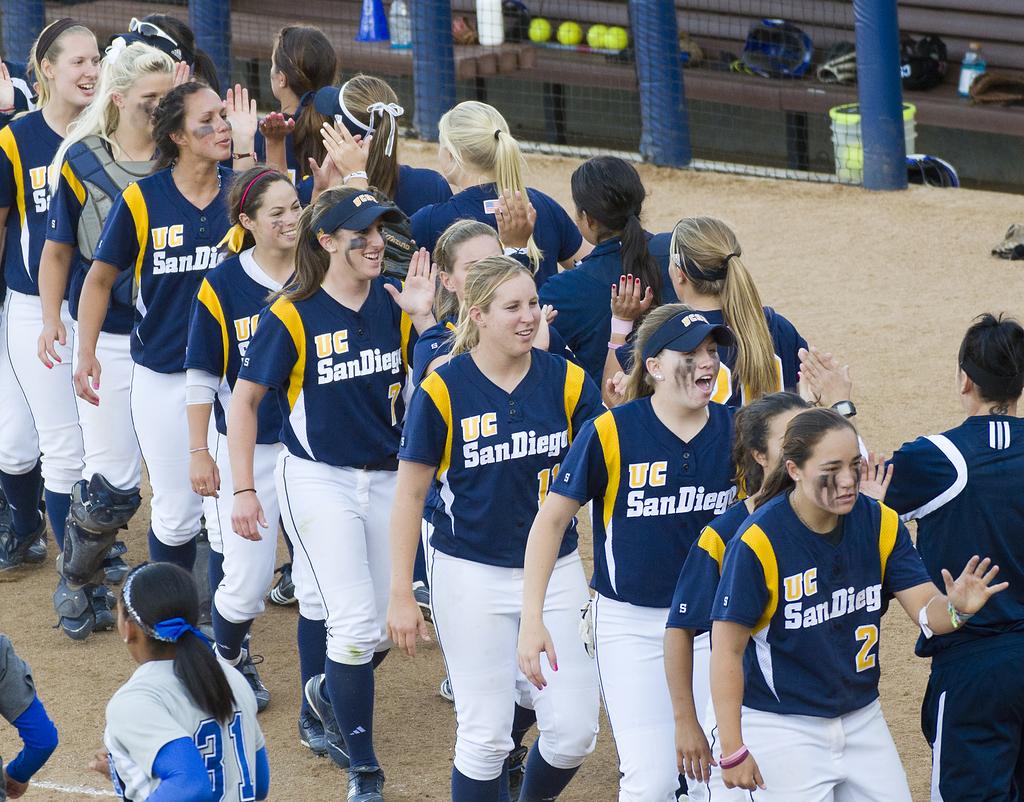What city is listed on the shirts of the players wearing blue and yellow?
Keep it short and to the point. San diego. 